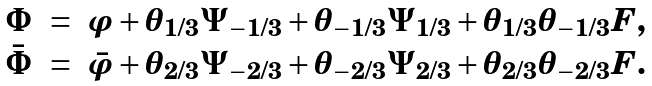Convert formula to latex. <formula><loc_0><loc_0><loc_500><loc_500>\begin{array} { l c r } \Phi & = & \varphi + \theta _ { 1 / 3 } \Psi _ { - 1 / 3 } + \theta _ { - 1 / 3 } \Psi _ { 1 / 3 } + \theta _ { 1 / 3 } \theta _ { - 1 / 3 } F , \\ \bar { \Phi } & = & \bar { \varphi } + \theta _ { 2 / 3 } \Psi _ { - 2 / 3 } + \theta _ { - 2 / 3 } \Psi _ { 2 / 3 } + \theta _ { 2 / 3 } \theta _ { - 2 / 3 } F . \end{array}</formula> 